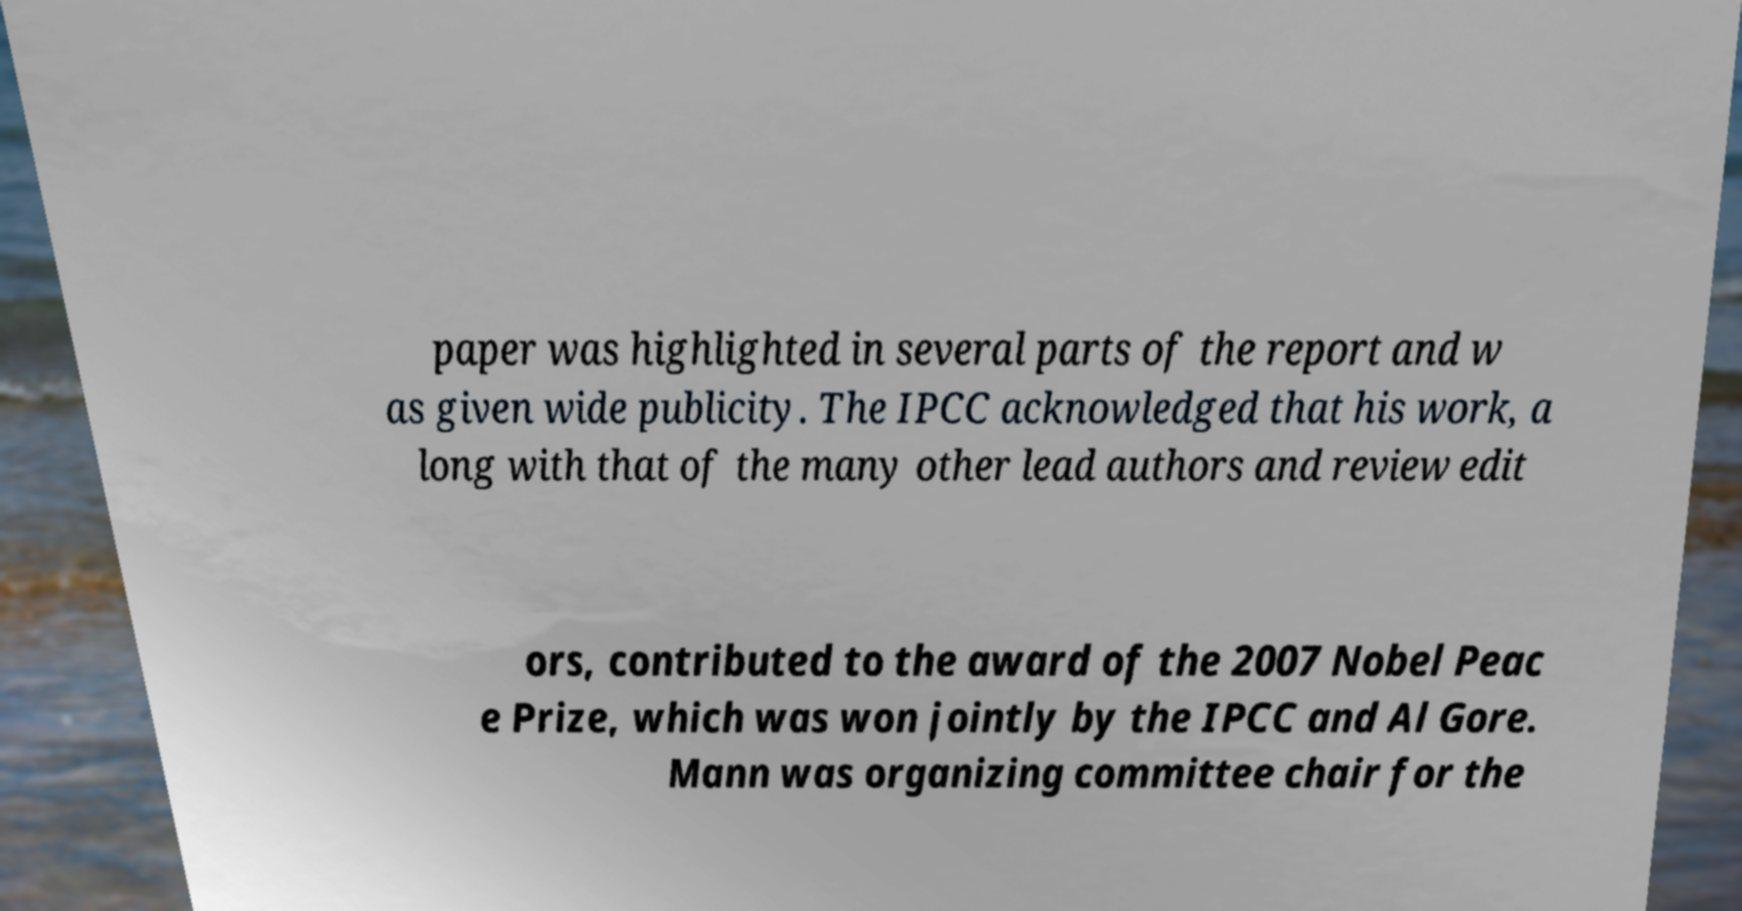What messages or text are displayed in this image? I need them in a readable, typed format. paper was highlighted in several parts of the report and w as given wide publicity. The IPCC acknowledged that his work, a long with that of the many other lead authors and review edit ors, contributed to the award of the 2007 Nobel Peac e Prize, which was won jointly by the IPCC and Al Gore. Mann was organizing committee chair for the 